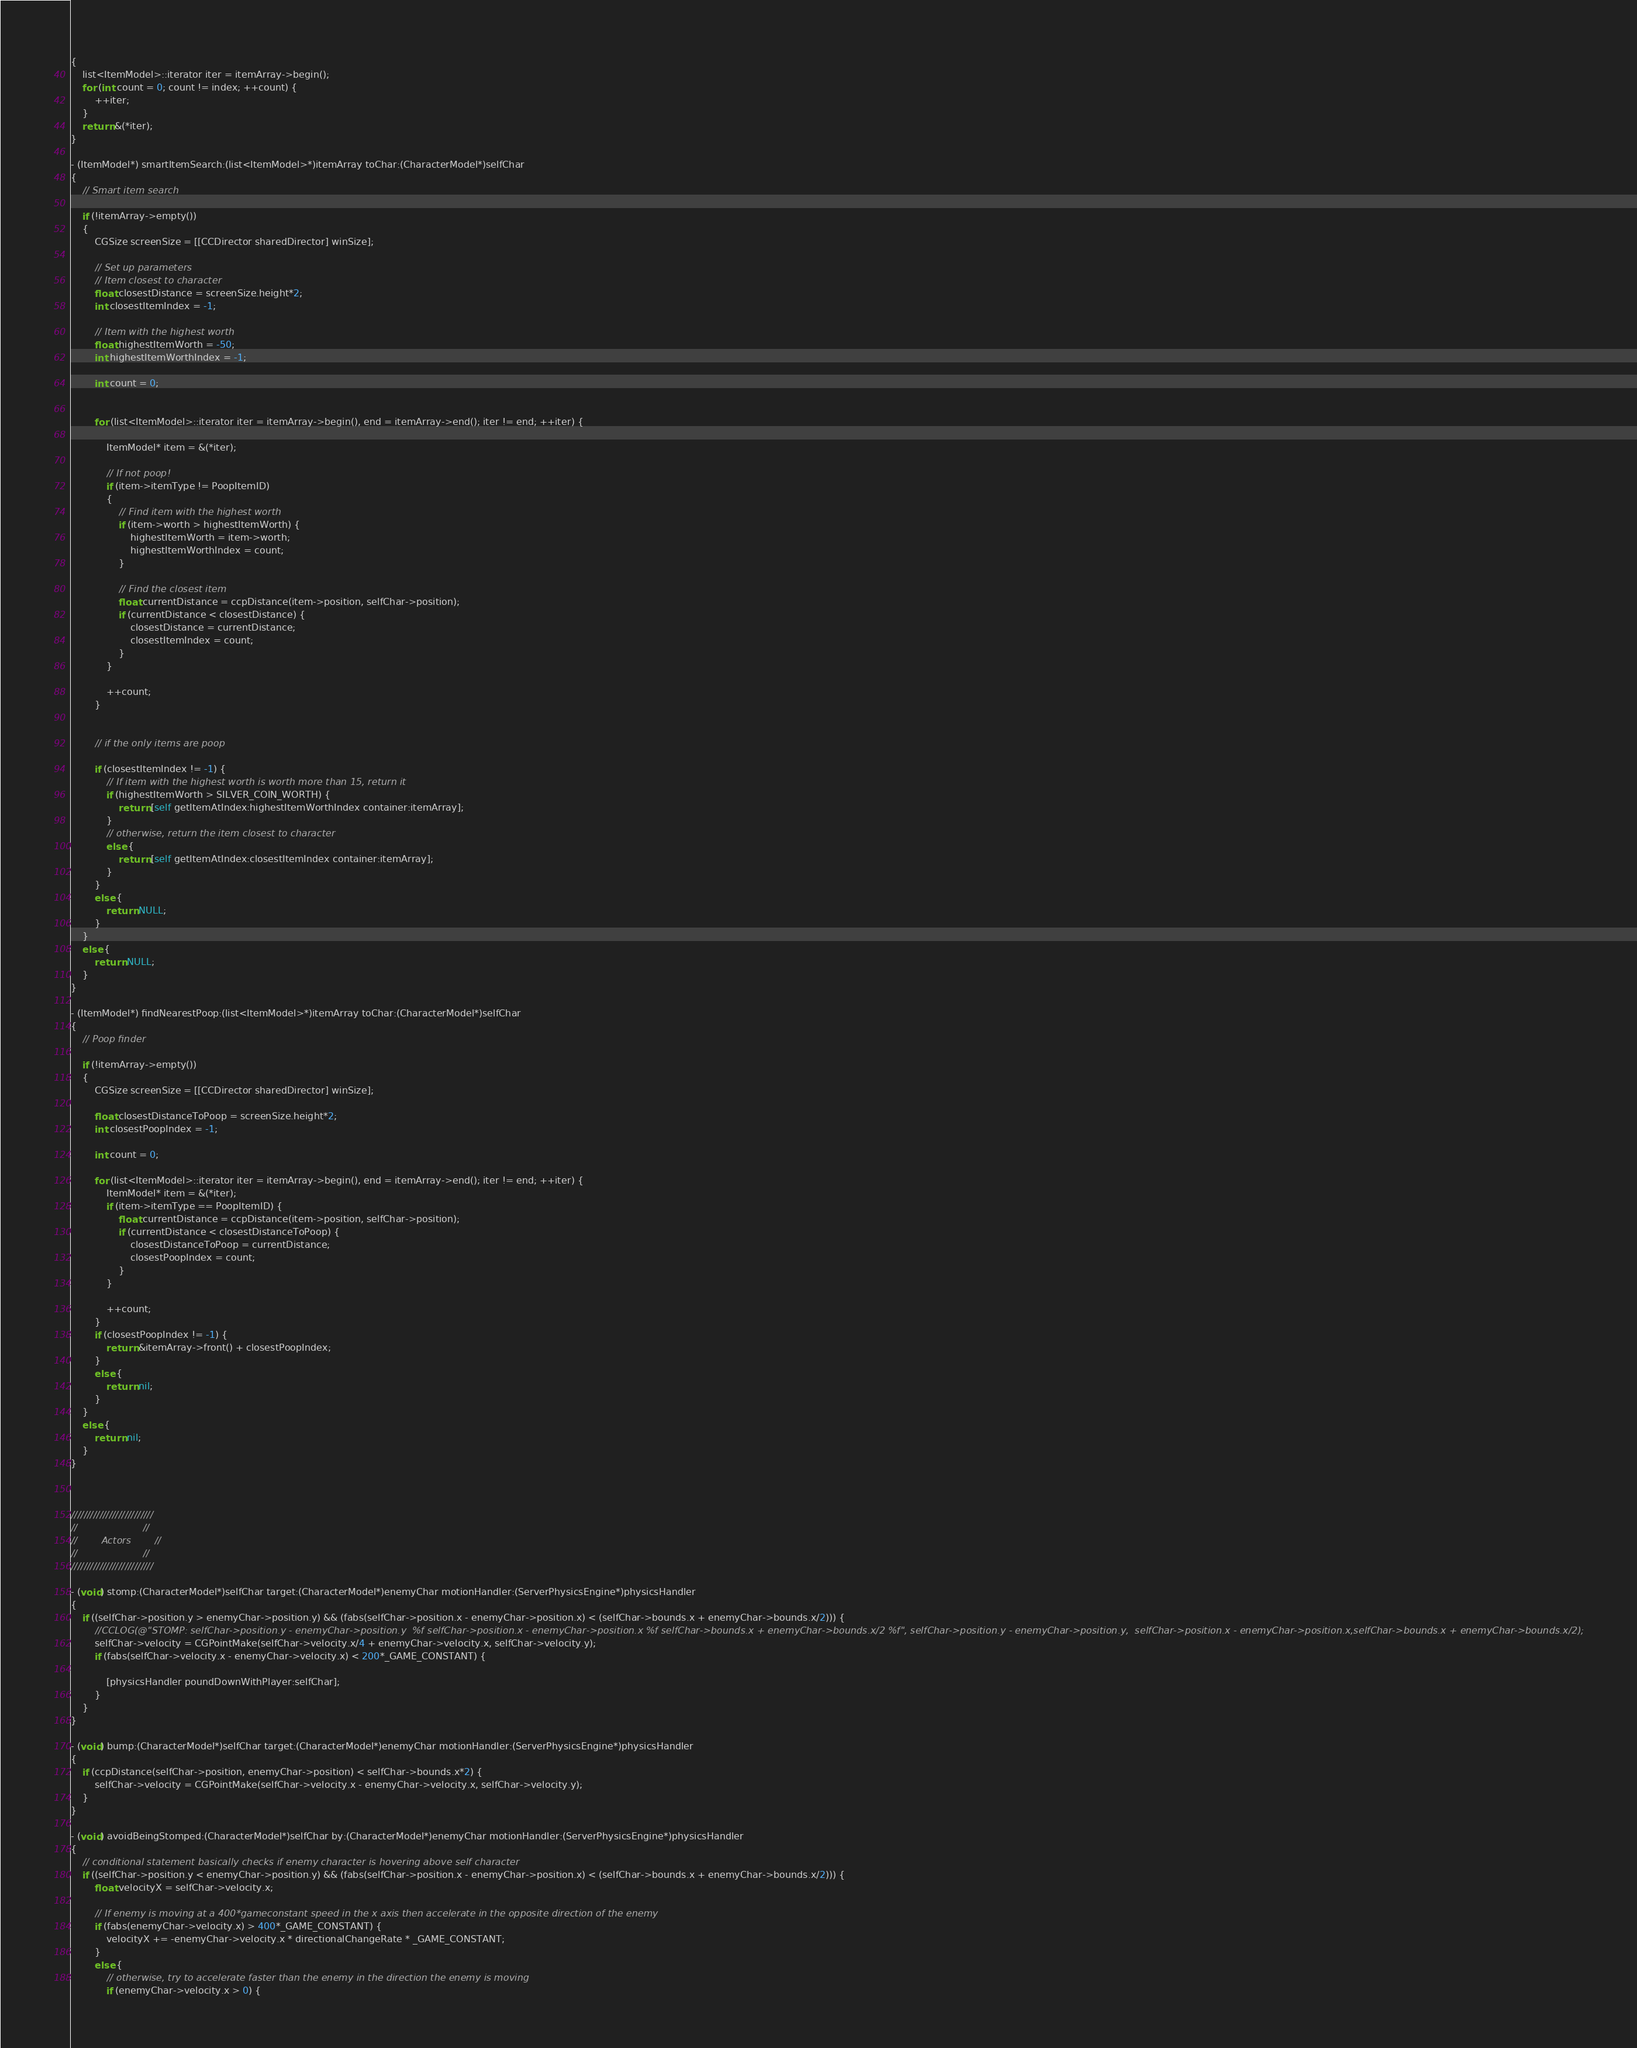<code> <loc_0><loc_0><loc_500><loc_500><_ObjectiveC_>{
	list<ItemModel>::iterator iter = itemArray->begin();
	for (int count = 0; count != index; ++count) {
		++iter;
	}
	return &(*iter);
}

- (ItemModel*) smartItemSearch:(list<ItemModel>*)itemArray toChar:(CharacterModel*)selfChar
{	
	// Smart item search
	
	if (!itemArray->empty())
	{
		CGSize screenSize = [[CCDirector sharedDirector] winSize];
		
		// Set up parameters
		// Item closest to character
		float closestDistance = screenSize.height*2;
		int closestItemIndex = -1;
		
		// Item with the highest worth
		float highestItemWorth = -50;
		int highestItemWorthIndex = -1;
		
		int count = 0;
		
		
		for (list<ItemModel>::iterator iter = itemArray->begin(), end = itemArray->end(); iter != end; ++iter) {
			
			ItemModel* item = &(*iter);
			
			// If not poop!
			if (item->itemType != PoopItemID) 
			{
				// Find item with the highest worth
				if (item->worth > highestItemWorth) {
					highestItemWorth = item->worth;
					highestItemWorthIndex = count;
				}
				
				// Find the closest item 
				float currentDistance = ccpDistance(item->position, selfChar->position);
				if (currentDistance < closestDistance) {
					closestDistance = currentDistance;
					closestItemIndex = count;
				}
			}
			
			++count;
		}
		
		
		// if the only items are poop
		
		if (closestItemIndex != -1) {
			// If item with the highest worth is worth more than 15, return it
			if (highestItemWorth > SILVER_COIN_WORTH) {
				return [self getItemAtIndex:highestItemWorthIndex container:itemArray];
			}
			// otherwise, return the item closest to character
			else {
				return [self getItemAtIndex:closestItemIndex container:itemArray];
			}
		}
		else {
			return NULL;
		}
	}
	else {
		return NULL;
	}
}

- (ItemModel*) findNearestPoop:(list<ItemModel>*)itemArray toChar:(CharacterModel*)selfChar
{	
	// Poop finder
	
	if (!itemArray->empty())
	{
		CGSize screenSize = [[CCDirector sharedDirector] winSize];
		
		float closestDistanceToPoop = screenSize.height*2;
		int closestPoopIndex = -1;
		
		int count = 0;
		
		for (list<ItemModel>::iterator iter = itemArray->begin(), end = itemArray->end(); iter != end; ++iter) {
			ItemModel* item = &(*iter);
			if (item->itemType == PoopItemID) {
				float currentDistance = ccpDistance(item->position, selfChar->position);
				if (currentDistance < closestDistanceToPoop) {
					closestDistanceToPoop = currentDistance;
					closestPoopIndex = count;
				}
			}
			
			++count;
		}
		if (closestPoopIndex != -1) {
			return &itemArray->front() + closestPoopIndex;
		}
		else {
			return nil;
		}
	}
	else {
		return nil;
	}
}



//////////////////////////
//						//
//		  Actors		//
//						//
//////////////////////////

- (void) stomp:(CharacterModel*)selfChar target:(CharacterModel*)enemyChar motionHandler:(ServerPhysicsEngine*)physicsHandler
{
	if ((selfChar->position.y > enemyChar->position.y) && (fabs(selfChar->position.x - enemyChar->position.x) < (selfChar->bounds.x + enemyChar->bounds.x/2))) {
		//CCLOG(@"STOMP: selfChar->position.y - enemyChar->position.y  %f selfChar->position.x - enemyChar->position.x %f selfChar->bounds.x + enemyChar->bounds.x/2 %f", selfChar->position.y - enemyChar->position.y,  selfChar->position.x - enemyChar->position.x,selfChar->bounds.x + enemyChar->bounds.x/2);
		selfChar->velocity = CGPointMake(selfChar->velocity.x/4 + enemyChar->velocity.x, selfChar->velocity.y);
		if (fabs(selfChar->velocity.x - enemyChar->velocity.x) < 200*_GAME_CONSTANT) {
			
			[physicsHandler poundDownWithPlayer:selfChar];
		}
	}
}

- (void) bump:(CharacterModel*)selfChar target:(CharacterModel*)enemyChar motionHandler:(ServerPhysicsEngine*)physicsHandler
{
	if (ccpDistance(selfChar->position, enemyChar->position) < selfChar->bounds.x*2) {
		selfChar->velocity = CGPointMake(selfChar->velocity.x - enemyChar->velocity.x, selfChar->velocity.y);
	}
}

- (void) avoidBeingStomped:(CharacterModel*)selfChar by:(CharacterModel*)enemyChar motionHandler:(ServerPhysicsEngine*)physicsHandler
{
	// conditional statement basically checks if enemy character is hovering above self character
	if ((selfChar->position.y < enemyChar->position.y) && (fabs(selfChar->position.x - enemyChar->position.x) < (selfChar->bounds.x + enemyChar->bounds.x/2))) {
		float velocityX = selfChar->velocity.x;
		
		// If enemy is moving at a 400*gameconstant speed in the x axis then accelerate in the opposite direction of the enemy
		if (fabs(enemyChar->velocity.x) > 400*_GAME_CONSTANT) {
			velocityX += -enemyChar->velocity.x * directionalChangeRate * _GAME_CONSTANT;
		}
		else {
			// otherwise, try to accelerate faster than the enemy in the direction the enemy is moving
			if (enemyChar->velocity.x > 0) {</code> 